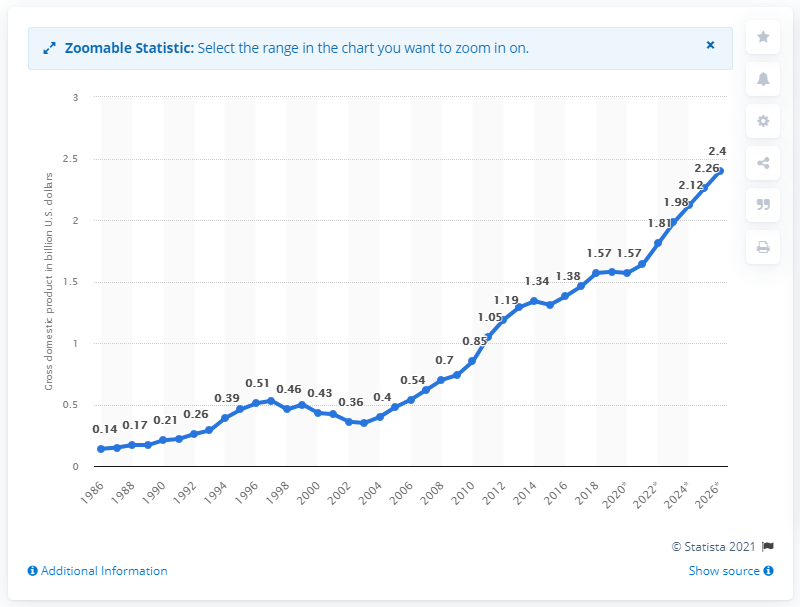Identify some key points in this picture. The gross domestic product of Solomon Islands in 2019 was 1.57. 